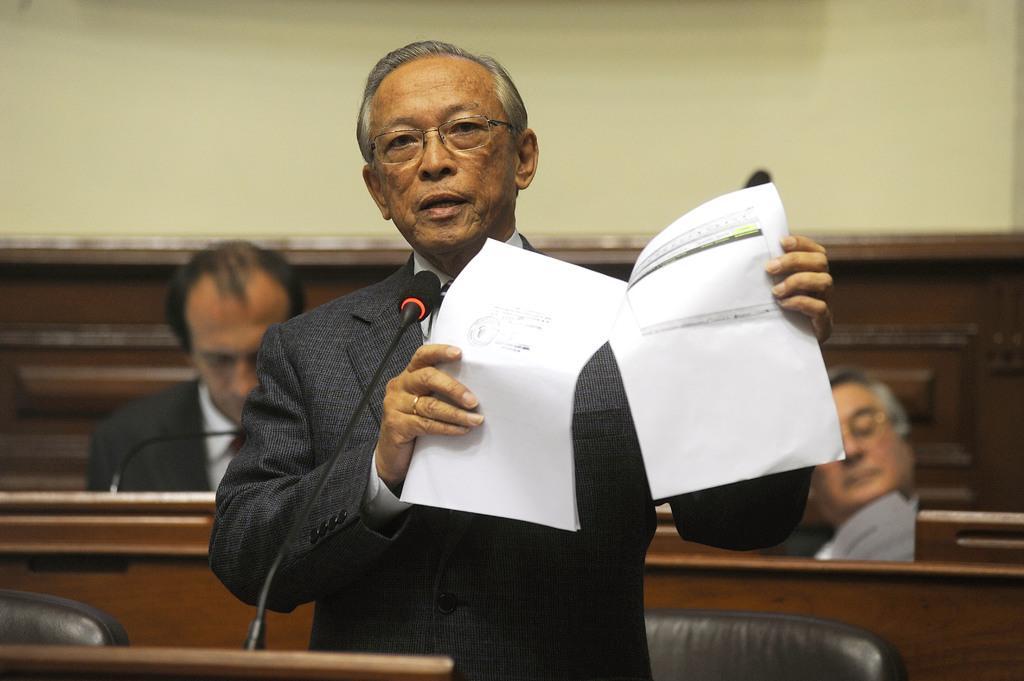Could you give a brief overview of what you see in this image? In this image I can see a person holding papers. In front I can see a mic. Back Side I can see two people sitting. I can see black color chair. The wall is in cream color. 